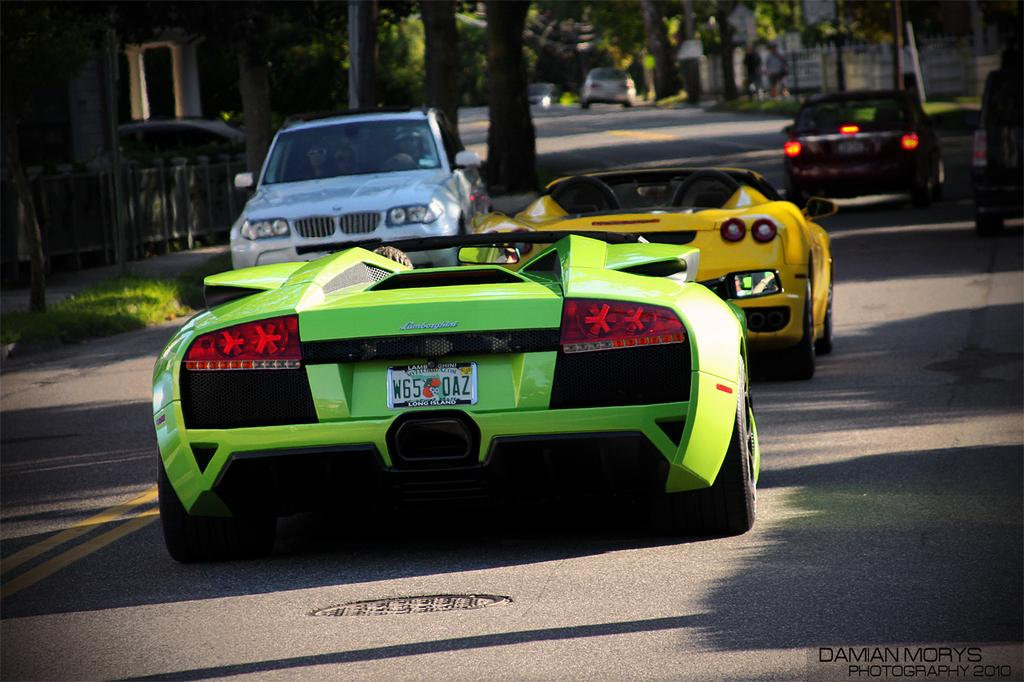What can be seen on the road in the image? There are cars on the road in the image. What type of vegetation is present alongside the road? Trees are present on either side of the road. What structure is located on the left side of the image? There is a building on the left side of the image. What scientific discovery is being made in the image? There is no indication of a scientific discovery being made in the image. How does the building support the road in the image? The building is not supporting the road in the image; it is simply located on the left side of the image. 